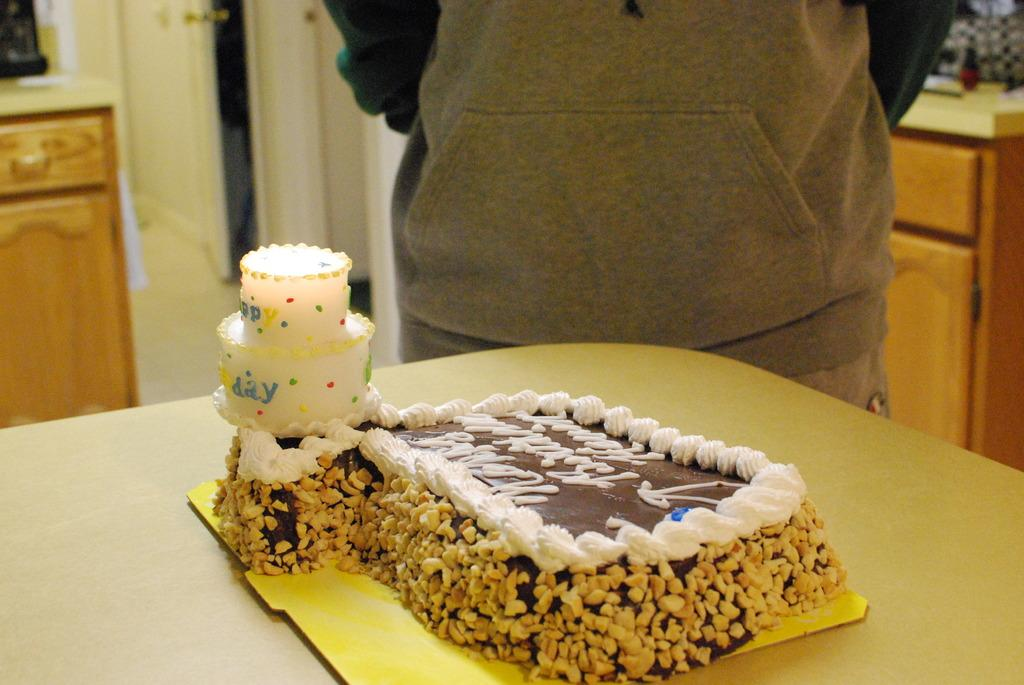What is the main piece of furniture in the image? There is a table in the image. What is placed on the table? There is a cake on the table. Is there anyone near the table? Yes, there is a person beside the table. What does the mom say about the cake in the image? There is no mention of a mom or any dialogue in the image, so it is not possible to answer that question. 